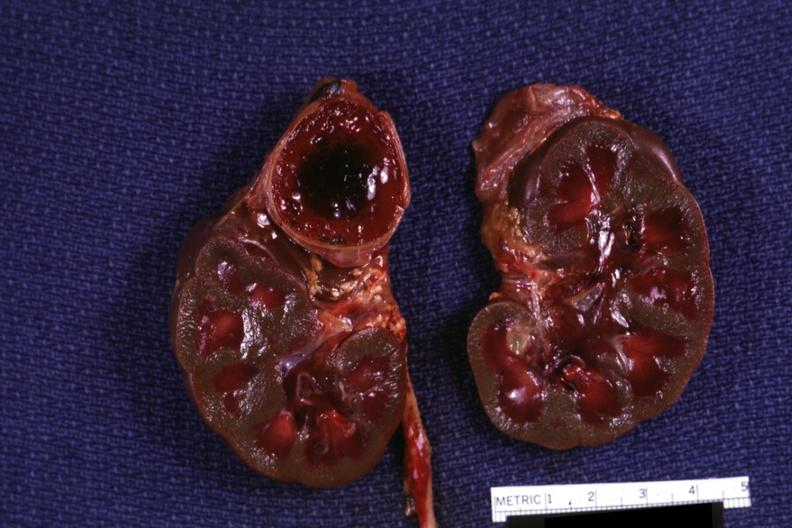s conjoined twins present?
Answer the question using a single word or phrase. No 